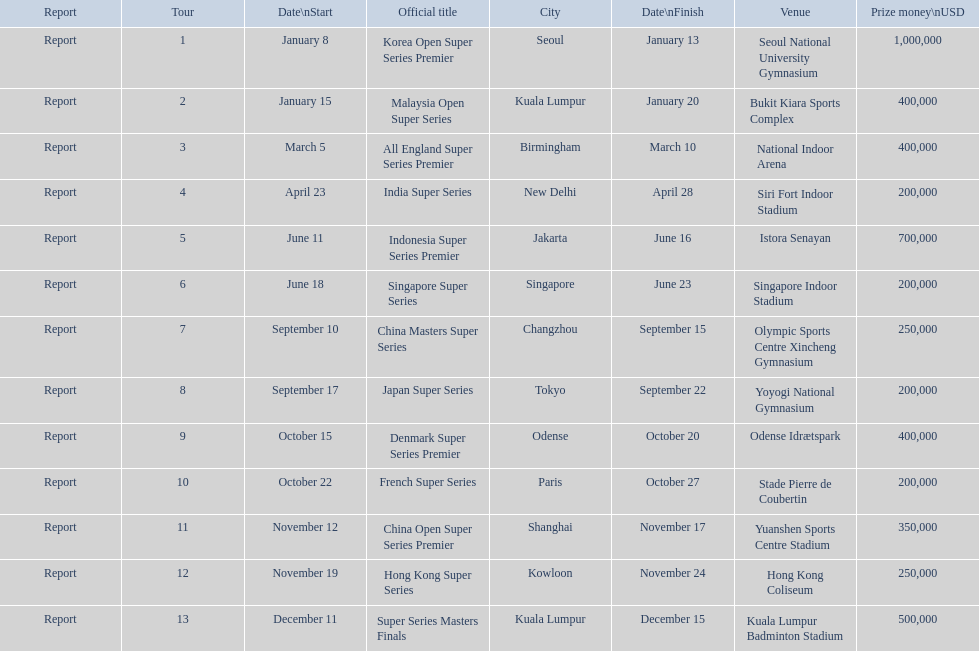How many occur in the last six months of the year? 7. Help me parse the entirety of this table. {'header': ['Report', 'Tour', 'Date\\nStart', 'Official title', 'City', 'Date\\nFinish', 'Venue', 'Prize money\\nUSD'], 'rows': [['Report', '1', 'January 8', 'Korea Open Super Series Premier', 'Seoul', 'January 13', 'Seoul National University Gymnasium', '1,000,000'], ['Report', '2', 'January 15', 'Malaysia Open Super Series', 'Kuala Lumpur', 'January 20', 'Bukit Kiara Sports Complex', '400,000'], ['Report', '3', 'March 5', 'All England Super Series Premier', 'Birmingham', 'March 10', 'National Indoor Arena', '400,000'], ['Report', '4', 'April 23', 'India Super Series', 'New Delhi', 'April 28', 'Siri Fort Indoor Stadium', '200,000'], ['Report', '5', 'June 11', 'Indonesia Super Series Premier', 'Jakarta', 'June 16', 'Istora Senayan', '700,000'], ['Report', '6', 'June 18', 'Singapore Super Series', 'Singapore', 'June 23', 'Singapore Indoor Stadium', '200,000'], ['Report', '7', 'September 10', 'China Masters Super Series', 'Changzhou', 'September 15', 'Olympic Sports Centre Xincheng Gymnasium', '250,000'], ['Report', '8', 'September 17', 'Japan Super Series', 'Tokyo', 'September 22', 'Yoyogi National Gymnasium', '200,000'], ['Report', '9', 'October 15', 'Denmark Super Series Premier', 'Odense', 'October 20', 'Odense Idrætspark', '400,000'], ['Report', '10', 'October 22', 'French Super Series', 'Paris', 'October 27', 'Stade Pierre de Coubertin', '200,000'], ['Report', '11', 'November 12', 'China Open Super Series Premier', 'Shanghai', 'November 17', 'Yuanshen Sports Centre Stadium', '350,000'], ['Report', '12', 'November 19', 'Hong Kong Super Series', 'Kowloon', 'November 24', 'Hong Kong Coliseum', '250,000'], ['Report', '13', 'December 11', 'Super Series Masters Finals', 'Kuala Lumpur', 'December 15', 'Kuala Lumpur Badminton Stadium', '500,000']]} 